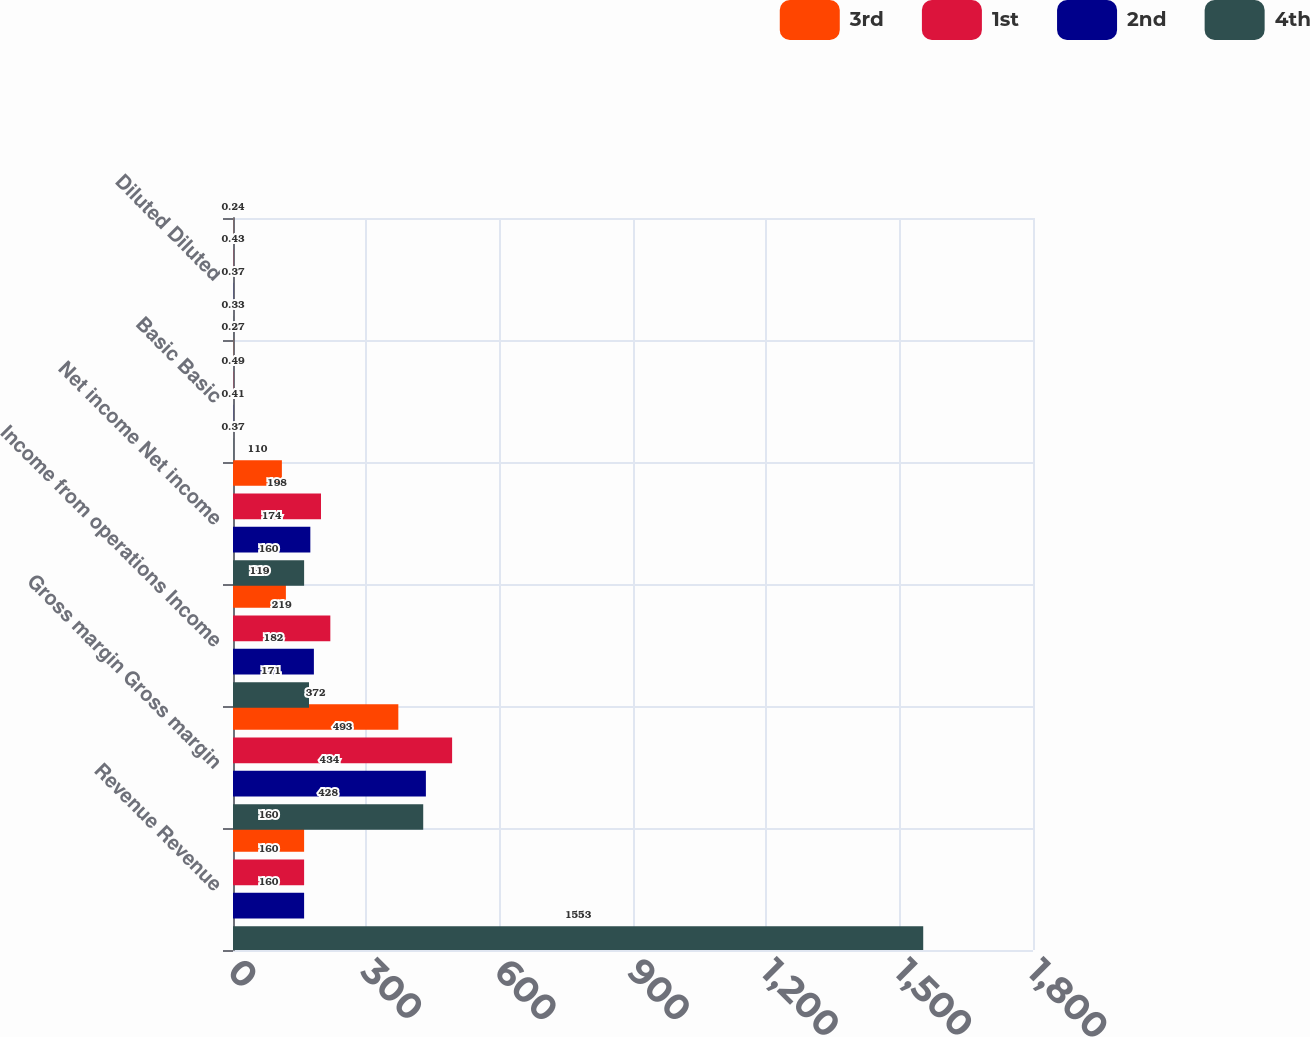<chart> <loc_0><loc_0><loc_500><loc_500><stacked_bar_chart><ecel><fcel>Revenue Revenue<fcel>Gross margin Gross margin<fcel>Income from operations Income<fcel>Net income Net income<fcel>Basic Basic<fcel>Diluted Diluted<nl><fcel>3rd<fcel>160<fcel>372<fcel>119<fcel>110<fcel>0.27<fcel>0.24<nl><fcel>1st<fcel>160<fcel>493<fcel>219<fcel>198<fcel>0.49<fcel>0.43<nl><fcel>2nd<fcel>160<fcel>434<fcel>182<fcel>174<fcel>0.41<fcel>0.37<nl><fcel>4th<fcel>1553<fcel>428<fcel>171<fcel>160<fcel>0.37<fcel>0.33<nl></chart> 